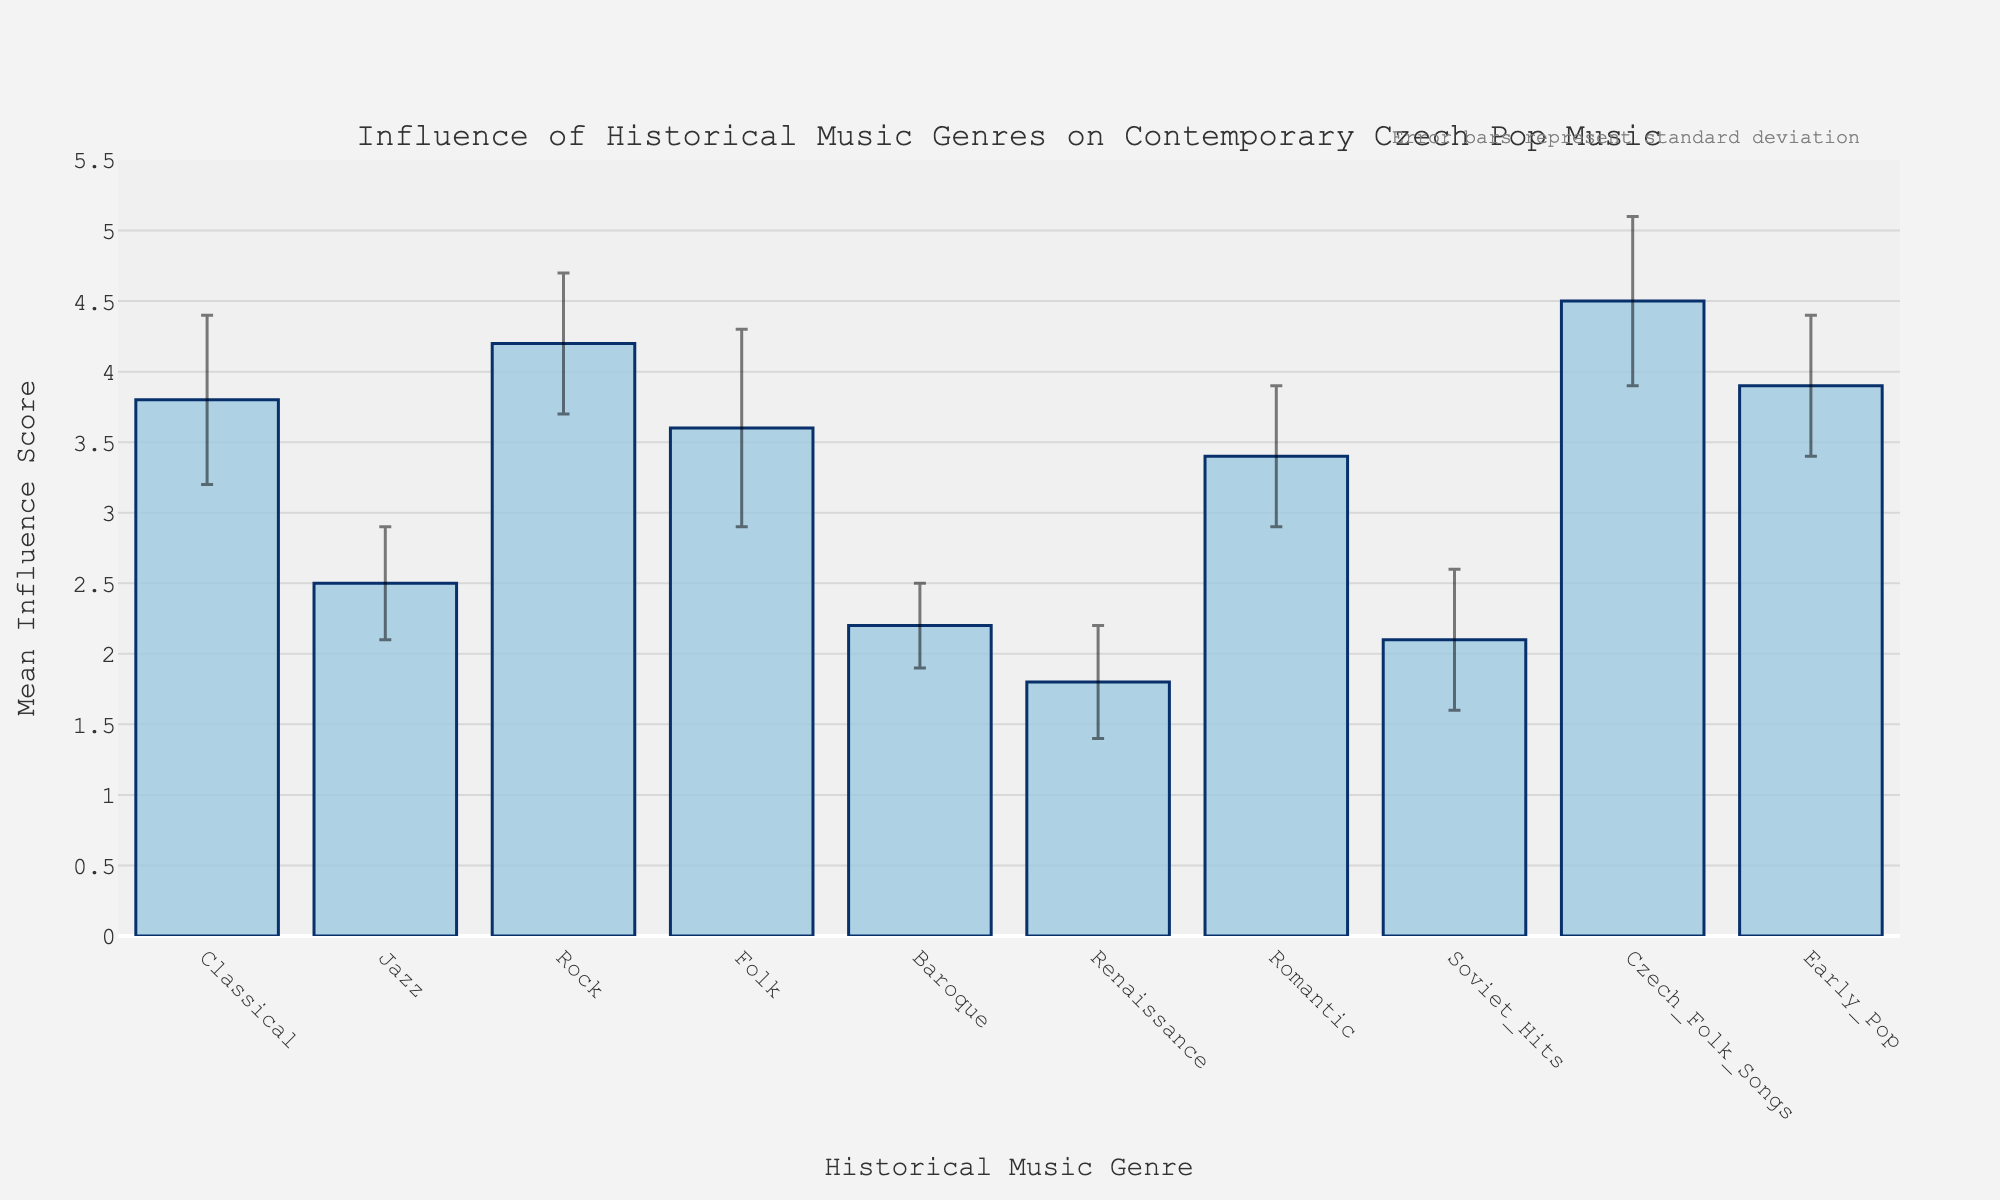What is the title of the figure? The title is usually placed at the top of the figure. In this case, it reads "Influence of Historical Music Genres on Contemporary Czech Pop Music".
Answer: Influence of Historical Music Genres on Contemporary Czech Pop Music Which genre has the highest mean influence score? The bar representing "Czech Folk Songs" reaches the highest point on the y-axis compared to the other bars, indicating it has the highest mean influence score.
Answer: Czech Folk Songs What is the mean influence score for Classical music? By looking at the corresponding bar for Classical music on the x-axis, we see it reaches 3.8 on the y-axis.
Answer: 3.8 Which genre has the smallest standard deviation? The smallest standard deviation corresponds to the shortest error bar. Baroque and Jazz both have the shortest error bars, but Baroque indicates 0.3 standard deviation as clearly mentioned.
Answer: Baroque Compare the mean influence scores of Rock and Jazz. Which is higher and by how much? Look at the bars for Rock and Jazz. Rock reaches 4.2, and Jazz reaches 2.5. Subtracting these gives 4.2 - 2.5 = 1.7.
Answer: Rock by 1.7 What is the sum of the mean influence scores for Baroque and Soviet Hits? Baroque has a mean influence of 2.2 and Soviet Hits has a mean influence of 2.1. Summing these gives 2.2 + 2.1 = 4.3.
Answer: 4.3 Which genres have a mean influence score greater than 4? Observing the bar heights, only Rock (4.2) and Czech Folk Songs (4.5) have mean influence scores above 4.
Answer: Rock and Czech Folk Songs Which genre shows the highest variability in influence? The variability is indicated by the length of the error bars. Folk has the largest error bar, implying the highest standard deviation of 0.7.
Answer: Folk How does the mean influence of Early Pop compare to Romantic? The bar for Early Pop reaches 3.9, while the bar for Romantic reaches 3.4, so Early Pop is higher.
Answer: Early Pop is higher What does the annotation at the top of the figure mention? The small text at the top of the figure notes that the error bars represent the standard deviation.
Answer: Error bars represent standard deviation 